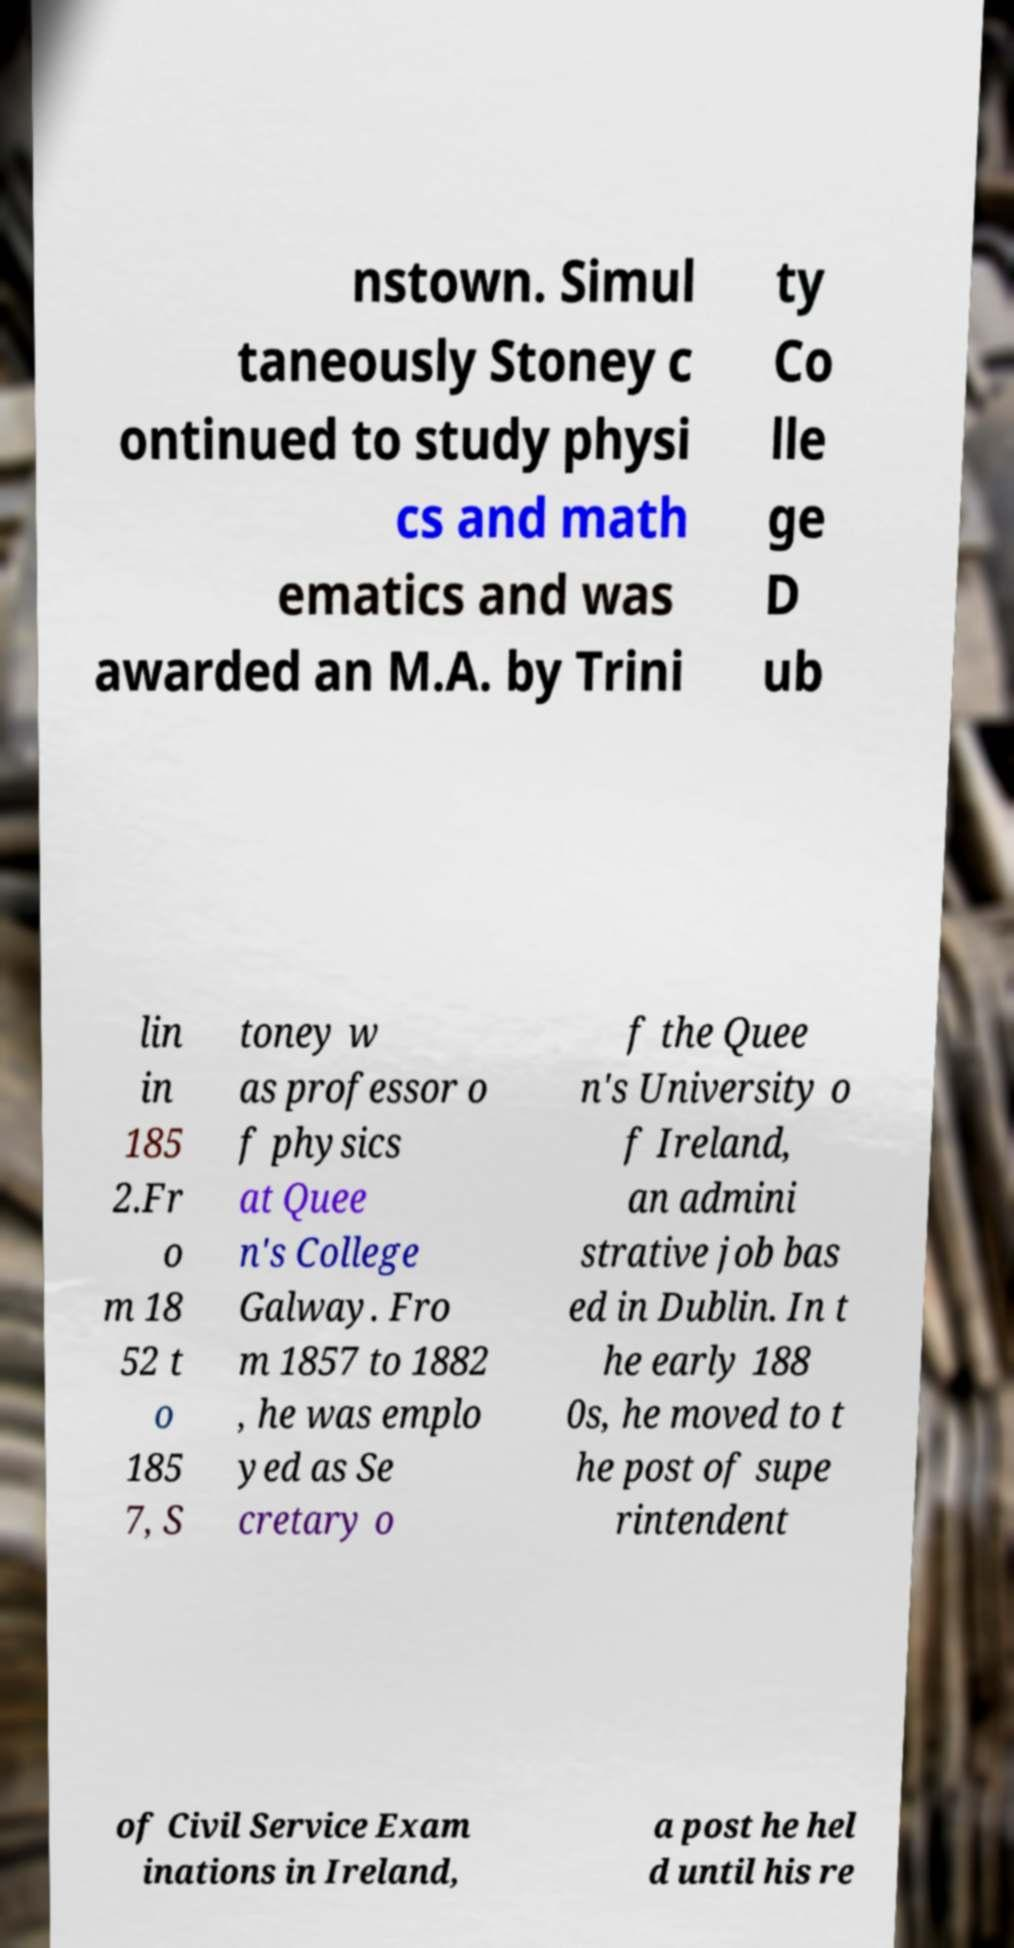Can you accurately transcribe the text from the provided image for me? nstown. Simul taneously Stoney c ontinued to study physi cs and math ematics and was awarded an M.A. by Trini ty Co lle ge D ub lin in 185 2.Fr o m 18 52 t o 185 7, S toney w as professor o f physics at Quee n's College Galway. Fro m 1857 to 1882 , he was emplo yed as Se cretary o f the Quee n's University o f Ireland, an admini strative job bas ed in Dublin. In t he early 188 0s, he moved to t he post of supe rintendent of Civil Service Exam inations in Ireland, a post he hel d until his re 